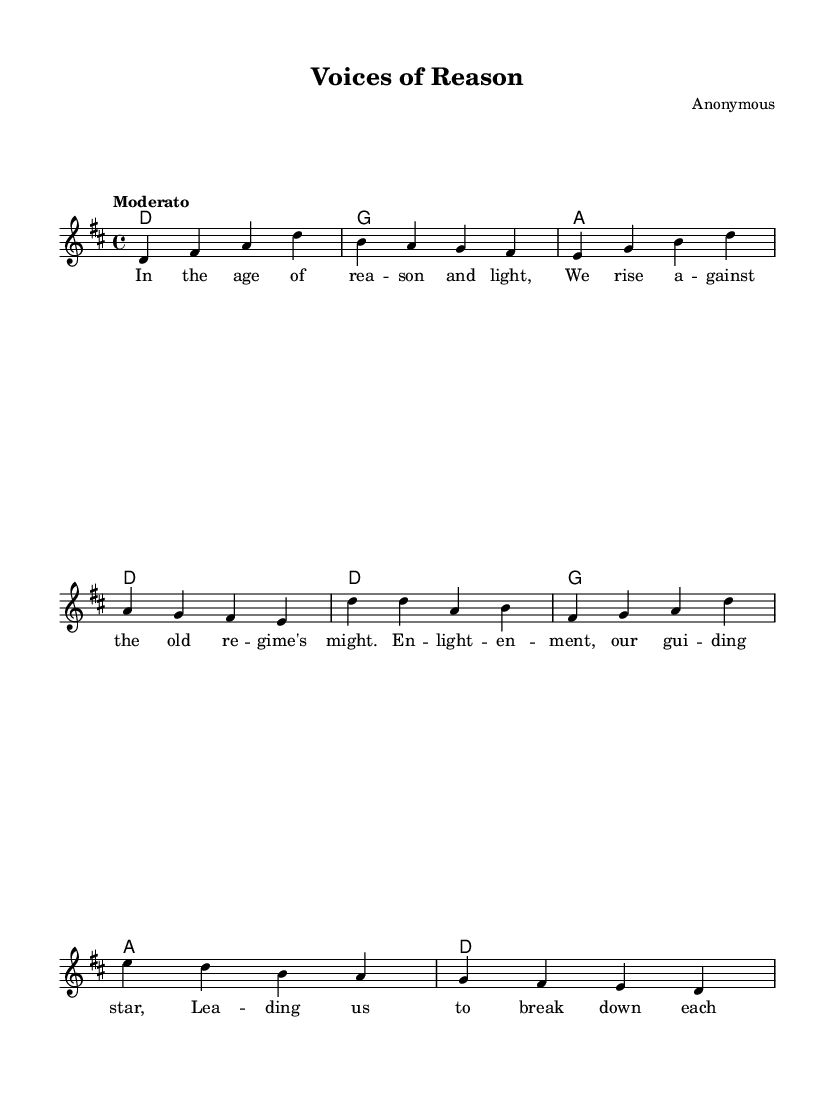What is the key signature of this music? The key signature is D major, which has two sharps (F# and C#).
Answer: D major What is the time signature of the piece? The time signature is specified at the beginning of the score as 4/4.
Answer: 4/4 What is the tempo marking of the music? The tempo marking is "Moderato", indicating a moderate speed.
Answer: Moderato How many measures are there in the verse? The verse consists of four measures, as seen in the melody notation.
Answer: Four What is the first note of the melody? The first note of the melody is D, which is indicated in the score.
Answer: D What is the main theme addressed in the lyrics? The main theme is about enlightenment and social change against the old regime.
Answer: Enlightenment What is the structure type of this music? The structure features a verse and a chorus format, typical of folk songs.
Answer: Verse and chorus 